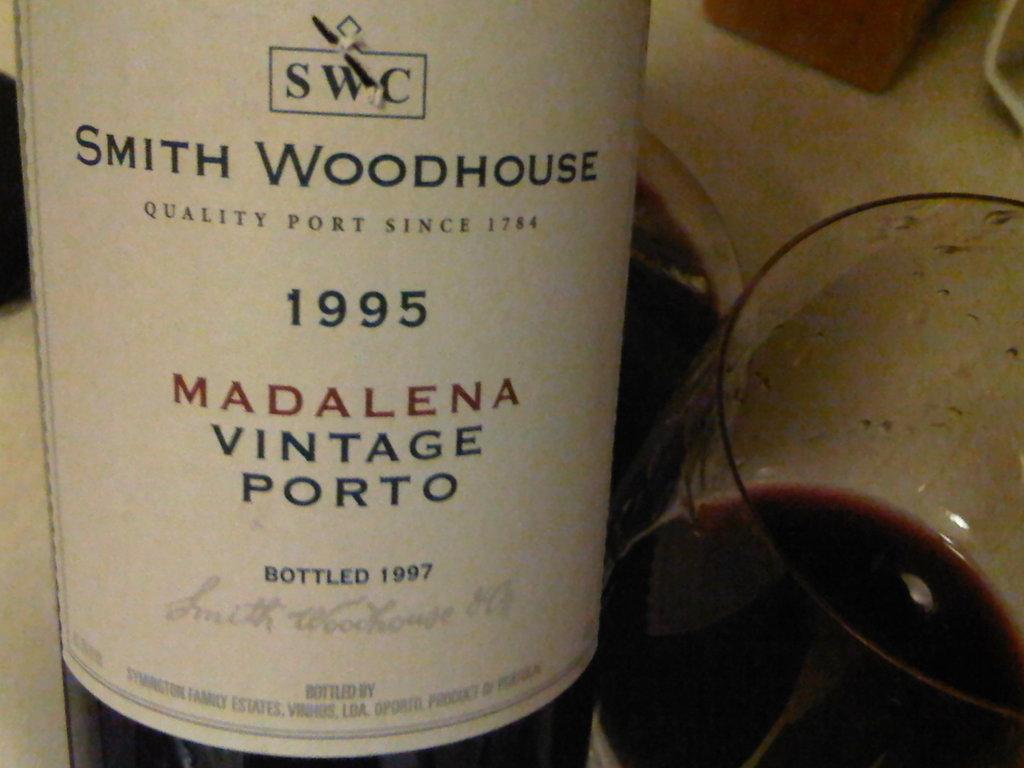What brandi s the wine?
Offer a terse response. Smith woodhouse. 